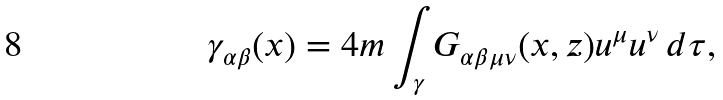Convert formula to latex. <formula><loc_0><loc_0><loc_500><loc_500>\gamma _ { \alpha \beta } ( x ) = 4 m \int _ { \gamma } G _ { \alpha \beta \mu \nu } ( x , z ) u ^ { \mu } u ^ { \nu } \, d \tau ,</formula> 